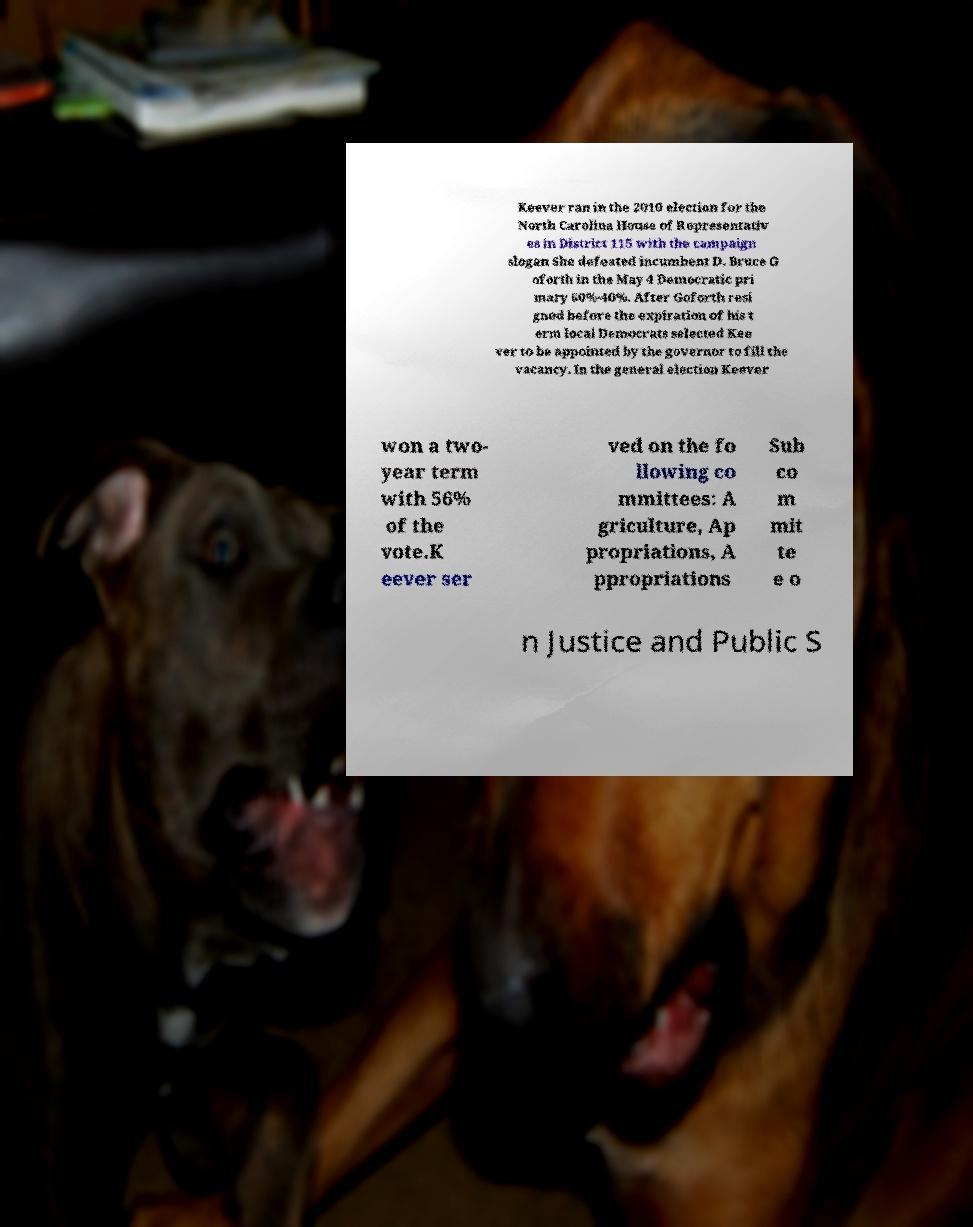Please read and relay the text visible in this image. What does it say? Keever ran in the 2010 election for the North Carolina House of Representativ es in District 115 with the campaign slogan She defeated incumbent D. Bruce G oforth in the May 4 Democratic pri mary 60%-40%. After Goforth resi gned before the expiration of his t erm local Democrats selected Kee ver to be appointed by the governor to fill the vacancy. In the general election Keever won a two- year term with 56% of the vote.K eever ser ved on the fo llowing co mmittees: A griculture, Ap propriations, A ppropriations Sub co m mit te e o n Justice and Public S 